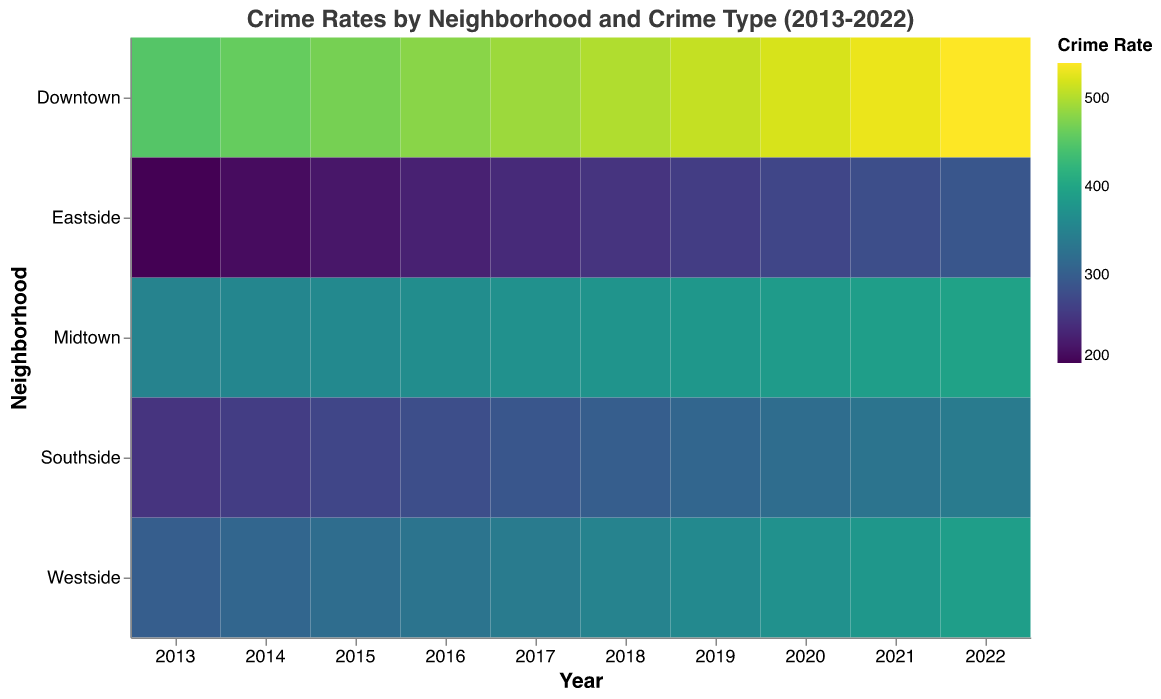What is the title of the heatmap? The title is located at the top center of the heatmap and states the subject of the visualization.
Answer: Crime Rates by Neighborhood and Crime Type (2013-2022) Which neighborhood had the highest number of thefts in the year 2022? Look for the 2022 column and identify which row (neighborhood) has the darkest color. Darker colors in this heatmap represent higher values.
Answer: Downtown How has the number of drug offenses in Midtown changed from 2013 to 2022? Compare the values for drug offenses in Midtown for the years 2013 and 2022. 2022 value (125) - 2013 value (80) = 45, so it has increased by 45.
Answer: Increased by 45 Which neighborhood had the lowest number of burglaries in 2015? Identify the 2015 column and look for the lightest color in the burglary field. Lighter colors indicate lower values.
Answer: Eastside How many drug offenses were reported in Westside in 2020 and 2022 combined? Add the values for drug offenses in Westside for the years 2020 and 2022: 125 (2020) + 135 (2022) = 260.
Answer: 260 What is the average number of assaults in Eastside over the past decade? Sum the values for assaults in Eastside from 2013 to 2022 and divide by the number of years (10). (150+155+160+165+170+175+180+185+190+195)/10 = 178.
Answer: 178 Among all neighborhoods, which has the steadiest (least variable) trend in theft rates across the decade? Compare the color consistency for theft rates across all years for each neighborhood. The neighborhood with the most consistent shade over the years has the steadiest trend.
Answer: Southside Which year had the highest combined total of vandalism across all neighborhoods? Sum the values for vandalism in all neighborhoods for each year, then identify the year with the highest total sum. [Requires calculation for each year, e.g., For 2022: 410 (Downtown) + 210 (Midtown) + 60 (Eastside) + 310 (Westside) + 110 (Southside)]
Answer: 2013 In which year did the theft rate for Southside surpass the assault rate in the same neighborhood? Compare the values for theft and assault in Southside year by year. Identify the year where the value for theft is greater than the value for assault.
Answer: 2022 Which crime type had the most substantial increase in Downtown from 2013 to 2022? Calculate the difference for each crime type from 2013 to 2022 in Downtown, and identify the one with the highest increase. E.g., Vandalism increased by (410 - 500 = -90), etc.
Answer: Theft 